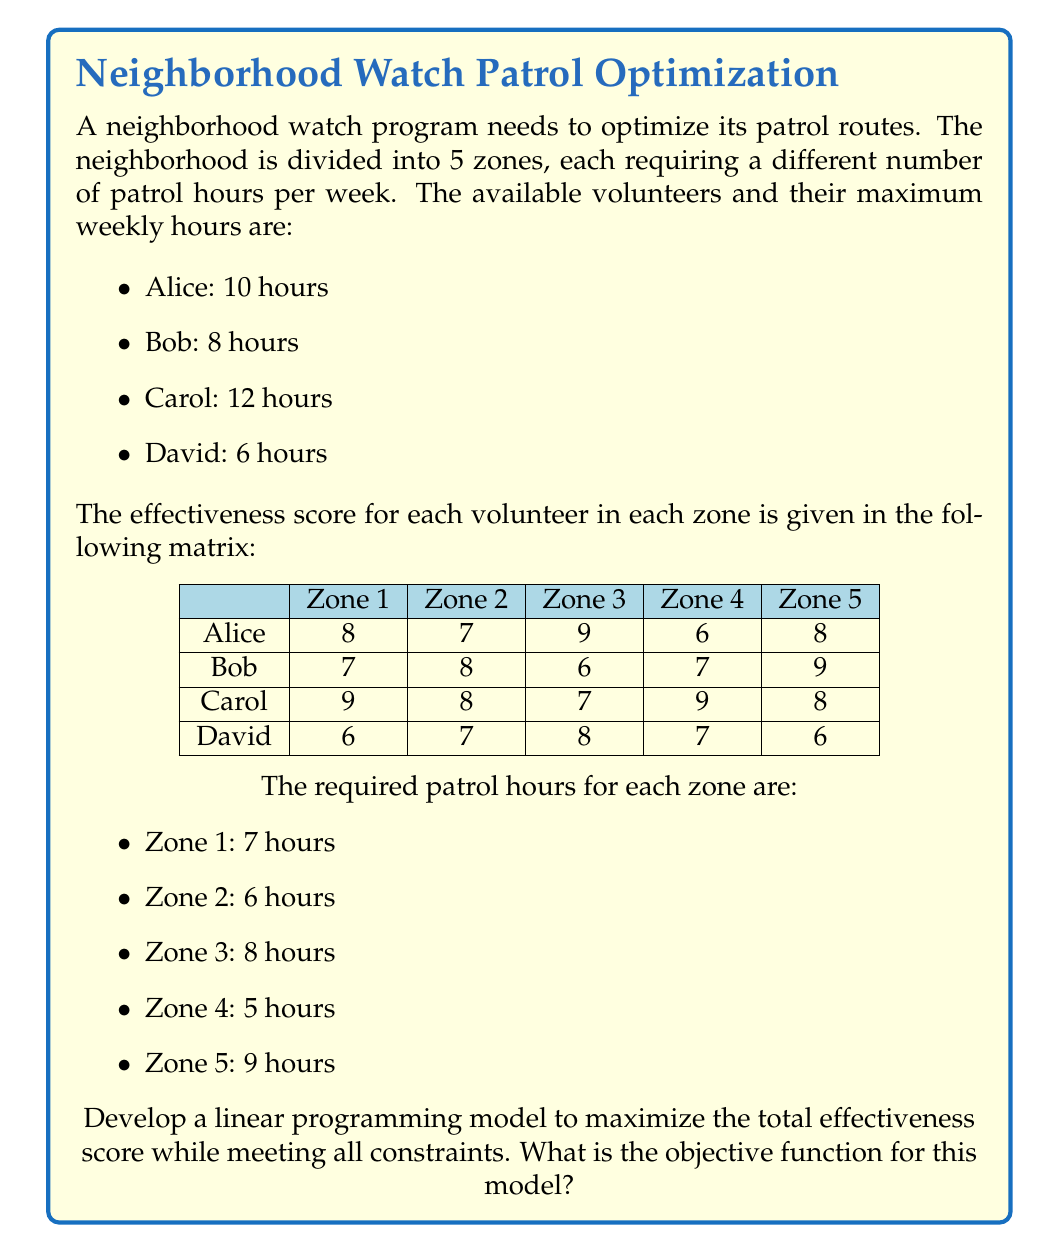Help me with this question. To develop the linear programming model, we need to define our decision variables, objective function, and constraints.

Step 1: Define decision variables
Let $x_{ij}$ be the number of hours volunteer i spends in zone j, where i = 1 to 4 (Alice, Bob, Carol, David) and j = 1 to 5 (Zones 1-5).

Step 2: Formulate the objective function
The objective is to maximize the total effectiveness score. We multiply each decision variable by its corresponding effectiveness score and sum them all:

$$\text{Maximize } Z = \sum_{i=1}^{4}\sum_{j=1}^{5} s_{ij}x_{ij}$$

Where $s_{ij}$ is the effectiveness score for volunteer i in zone j.

Expanding this, we get:

$$Z = 8x_{11} + 7x_{12} + 9x_{13} + 6x_{14} + 8x_{15} + 7x_{21} + 8x_{22} + 6x_{23} + 7x_{24} + 9x_{25} + 9x_{31} + 8x_{32} + 7x_{33} + 9x_{34} + 8x_{35} + 6x_{41} + 7x_{42} + 8x_{43} + 7x_{44} + 6x_{45}$$

Step 3: Define constraints
1. Volunteer time constraints:
   $$\sum_{j=1}^{5} x_{1j} \leq 10 \text{ (Alice)}$$
   $$\sum_{j=1}^{5} x_{2j} \leq 8 \text{ (Bob)}$$
   $$\sum_{j=1}^{5} x_{3j} \leq 12 \text{ (Carol)}$$
   $$\sum_{j=1}^{5} x_{4j} \leq 6 \text{ (David)}$$

2. Zone coverage constraints:
   $$\sum_{i=1}^{4} x_{i1} = 7 \text{ (Zone 1)}$$
   $$\sum_{i=1}^{4} x_{i2} = 6 \text{ (Zone 2)}$$
   $$\sum_{i=1}^{4} x_{i3} = 8 \text{ (Zone 3)}$$
   $$\sum_{i=1}^{4} x_{i4} = 5 \text{ (Zone 4)}$$
   $$\sum_{i=1}^{4} x_{i5} = 9 \text{ (Zone 5)}$$

3. Non-negativity constraints:
   $$x_{ij} \geq 0 \text{ for all i and j}$$

The objective function is the key component of this model that needs to be maximized while satisfying all the constraints.
Answer: $$Z = 8x_{11} + 7x_{12} + 9x_{13} + 6x_{14} + 8x_{15} + 7x_{21} + 8x_{22} + 6x_{23} + 7x_{24} + 9x_{25} + 9x_{31} + 8x_{32} + 7x_{33} + 9x_{34} + 8x_{35} + 6x_{41} + 7x_{42} + 8x_{43} + 7x_{44} + 6x_{45}$$ 